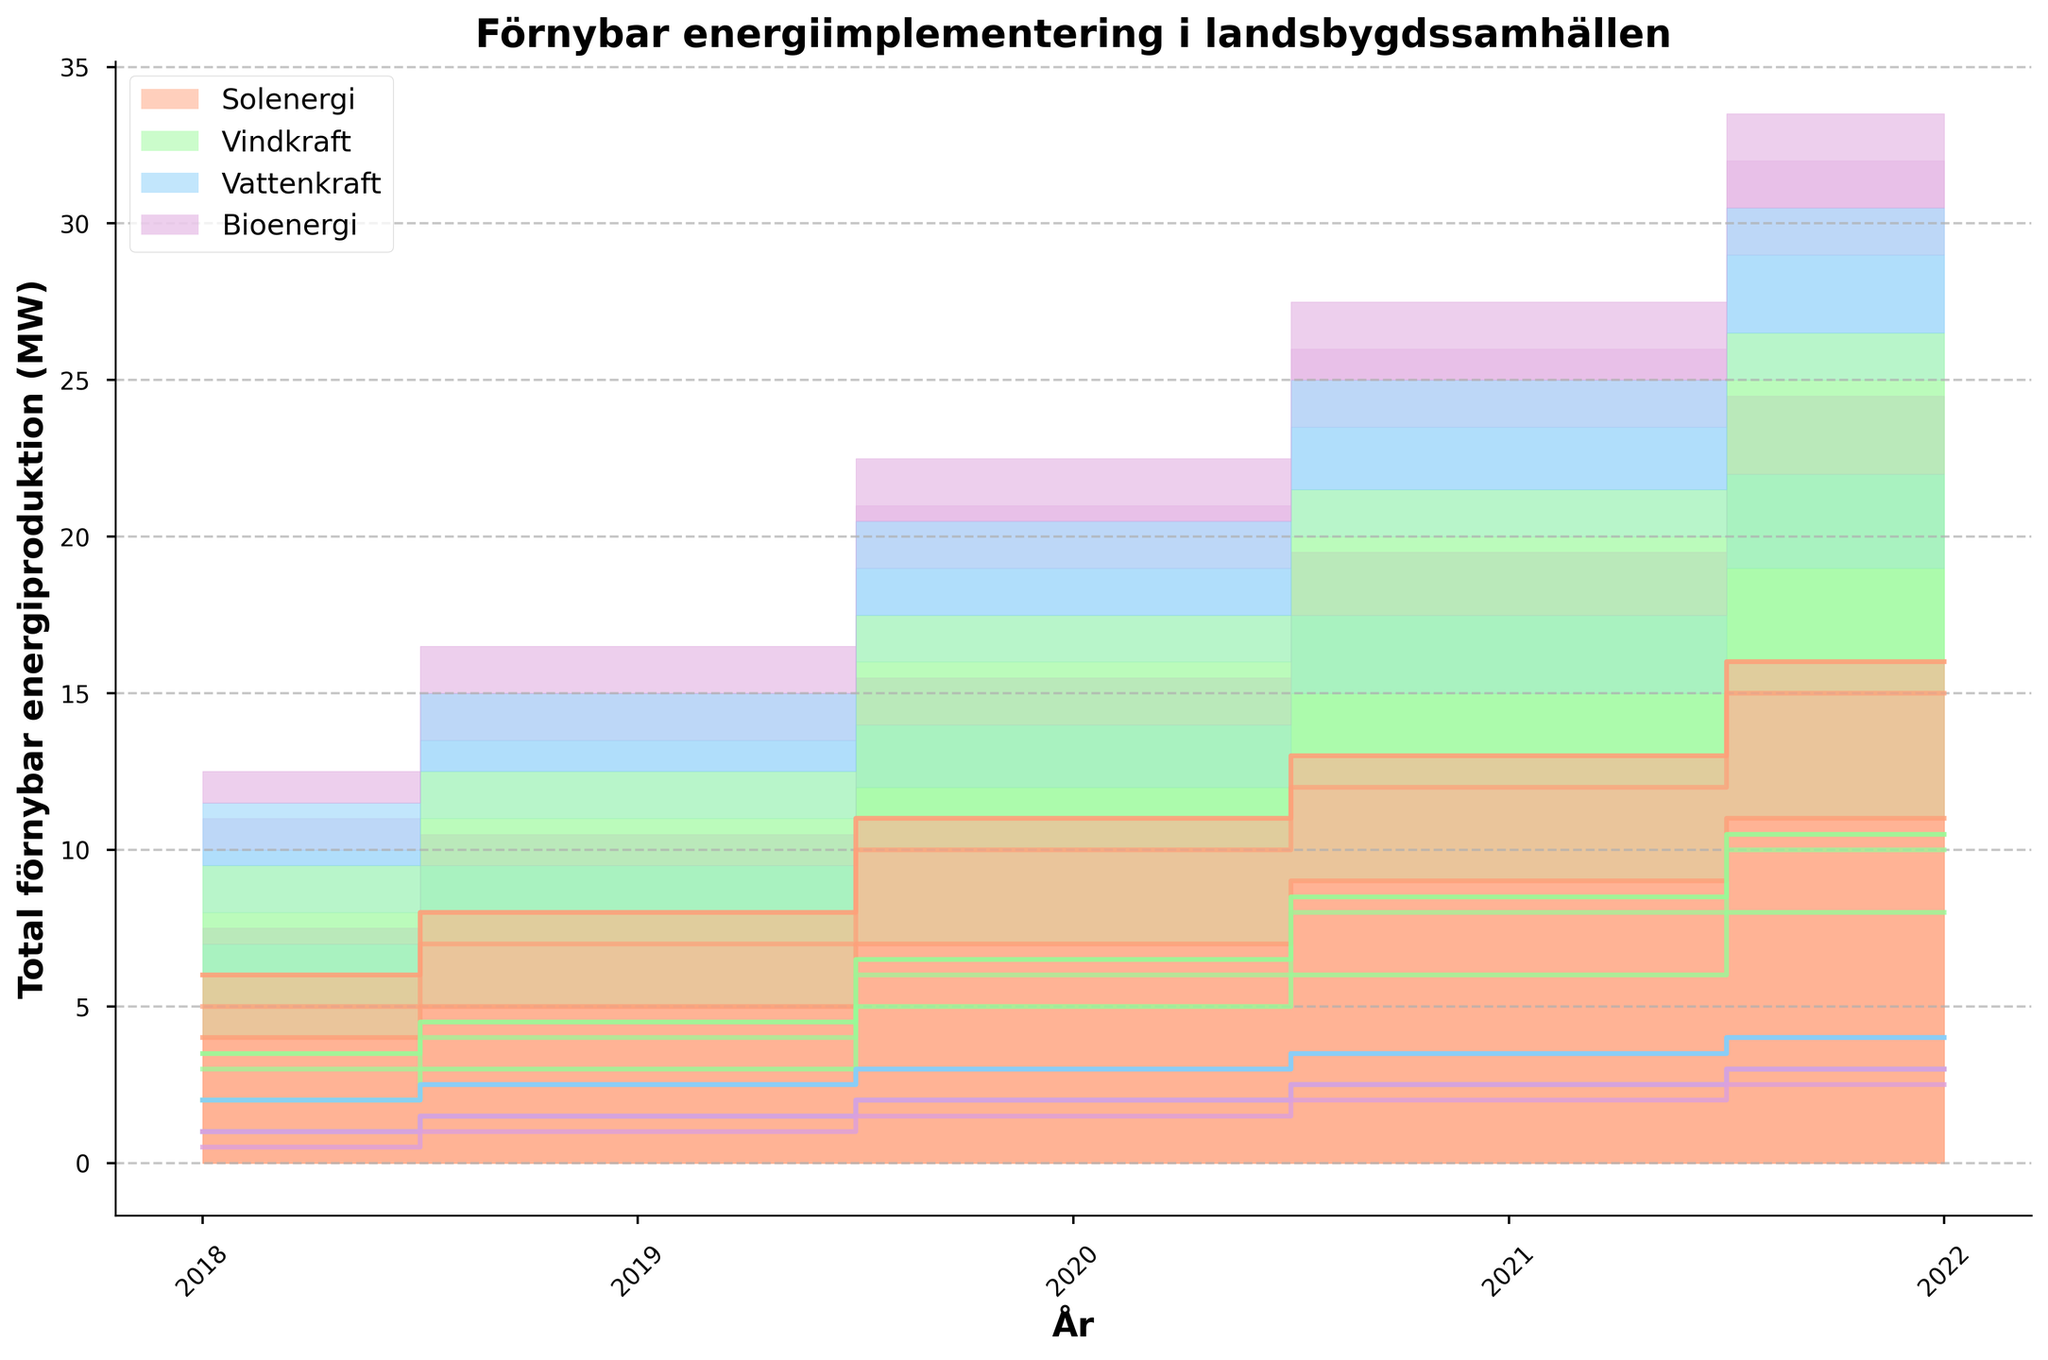What's the title of the chart? The title of the chart is usually found at the top and gives a brief summary of what the data represents. The given title is "Förnybar energiimplementering i landsbygdssamhällen".
Answer: Förnybar energiimplementering i landsbygdssamhällen What does the x-axis represent? The x-axis is labeled, and by examining the labels, we can see it represents years from 2018 to 2022.
Answer: Years Which community had the highest solar power implementation in 2022? To answer this, look at the step line for Solar Power (orange) in 2022 for each community. Community C reaches 16 MW, which is the highest.
Answer: Community C How much total renewable energy did Community A produce in 2021? Sum the values of all four energy types for Community A in 2021: Solar Power (12 MW) + Wind Power (8 MW) + Hydropower (3.5 MW) + Biomass Energy (2.5 MW). Adding these values gives the total.
Answer: 26 MW By how much did Wind Power increase in Community B from 2018 to 2022? Subtract the Wind Power value in 2018 (2 MW) from the value in 2022 (8 MW) for Community B.
Answer: 6 MW Which energy type had the least implementation across all communities? Compare all the step lines for Solar, Wind, Hydropower, and Biomass Energy. Biomass Energy (pink line) is consistently the lowest.
Answer: Biomass Energy Did Community B ever surpass Community C in Solar Power implementation? By comparing the step lines for Solar Power (orange) between Community B and Community C for each year, Community B never surpasses Community C at any point.
Answer: No Among all communities, how did the total energy implementation change from 2018 to 2022? To analyze this, sum the total values for all energy types across all communities for 2018 and 2022, then compare the sums for the two years.
Answer: It increased Which year saw the highest total renewable energy production across all communities? Sum the total production for all four energy types across all communities for each year, then identify the year with the highest sum.
Answer: 2022 